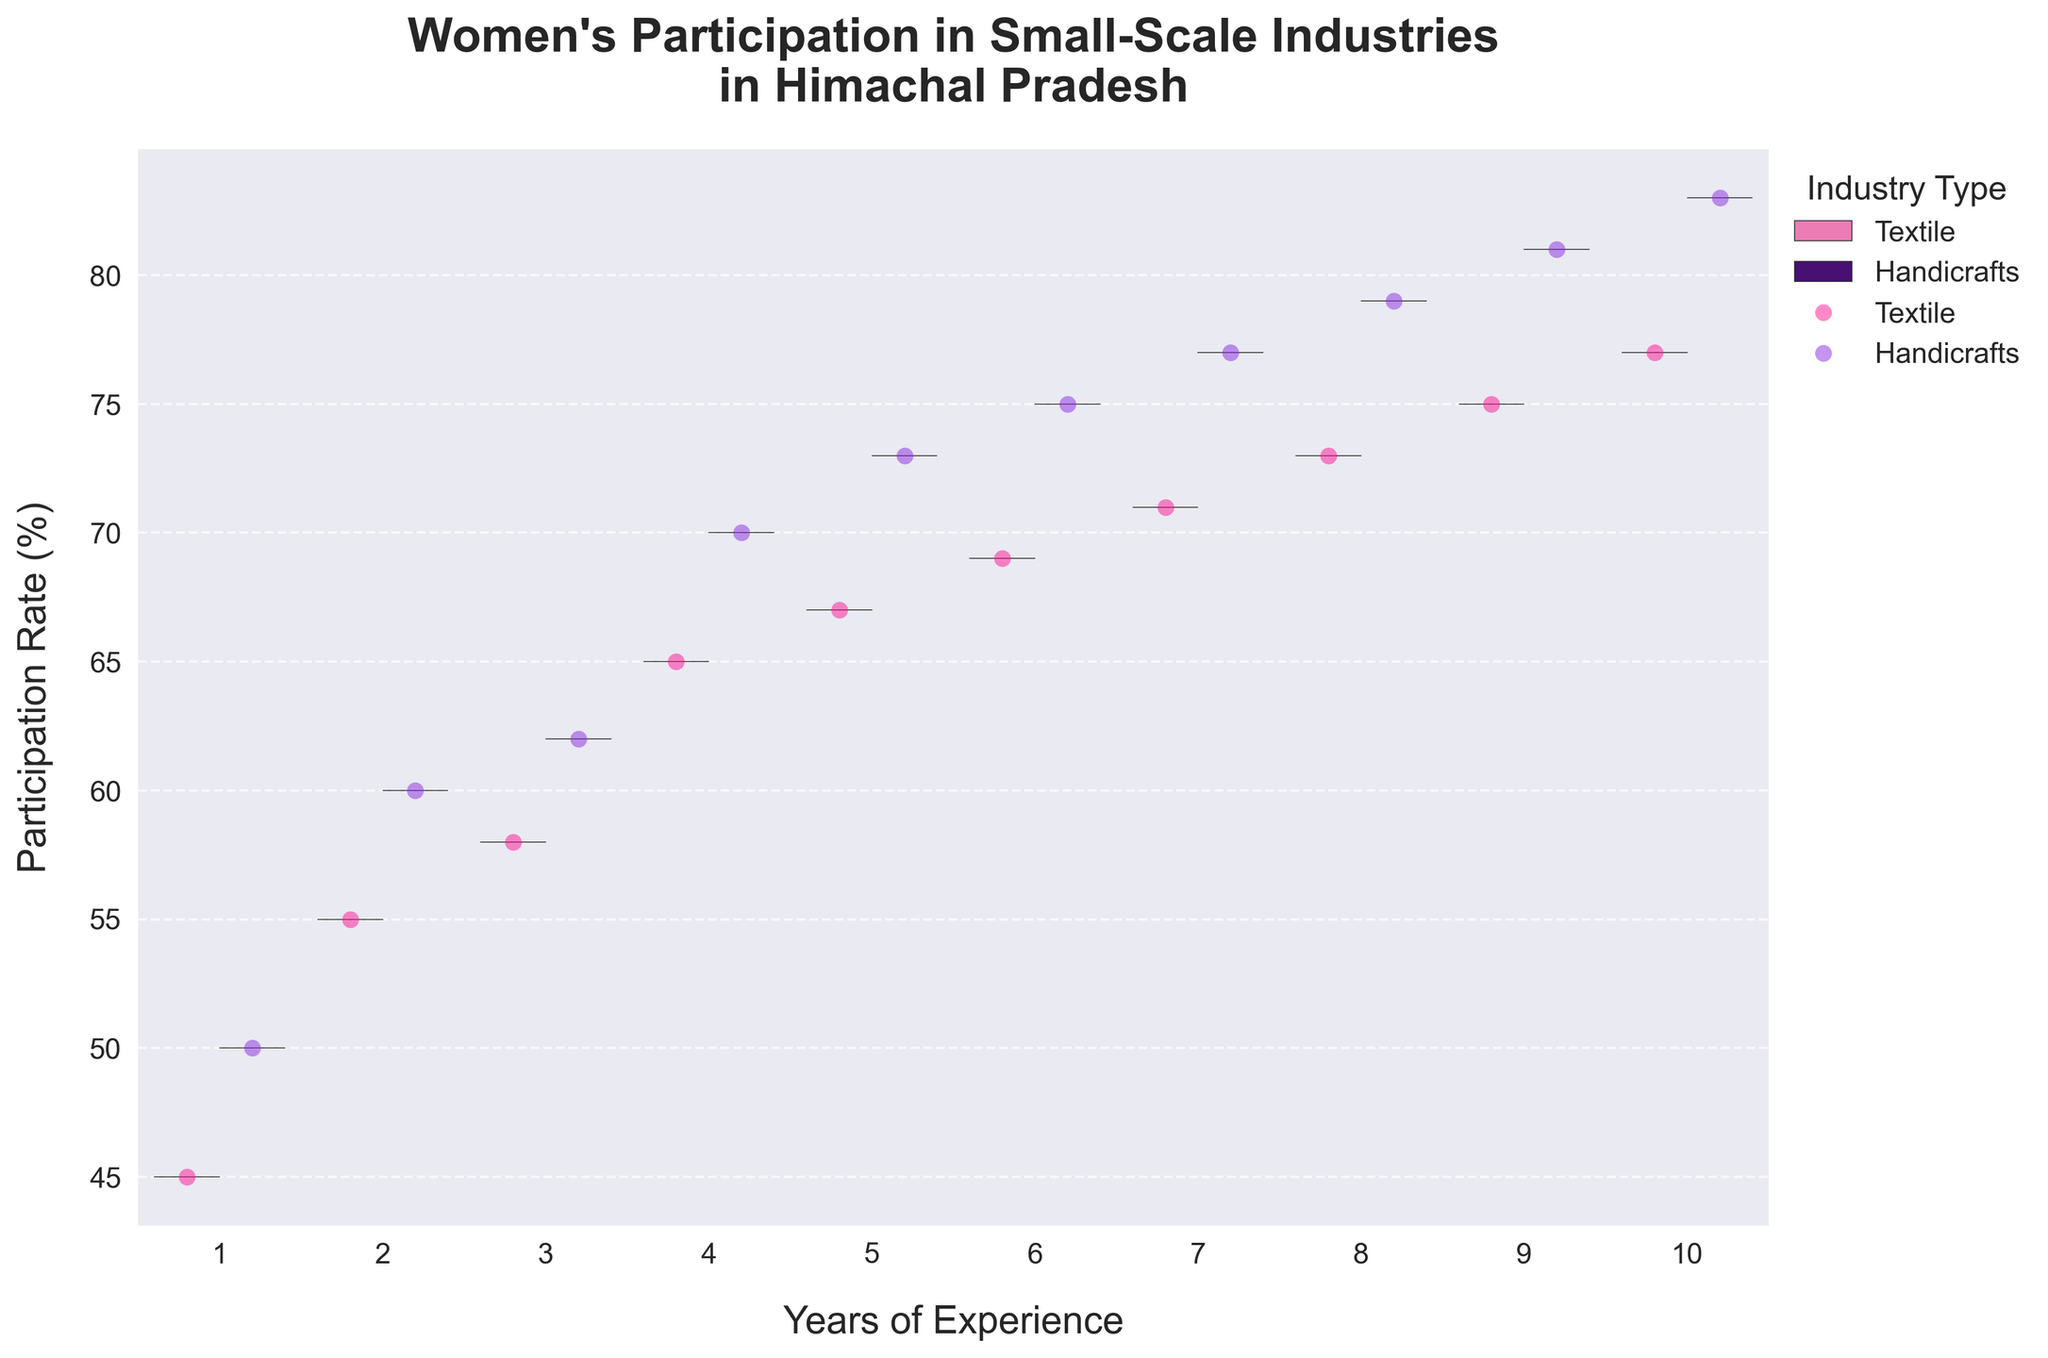How many years of experience are shown on the x-axis? The x-axis represents the years of experience. By counting the unique x-axis tick marks, we can determine the range of years shown.
Answer: 10 Which industry type shows higher participation rates across all years of experience? The violin plots and points indicate participation rates for Textile and Handicrafts. By comparing the positions of the median lines and the spread of each industry, Handicrafts consistently show higher participation rates across the years.
Answer: Handicrafts For women with 5 years of experience, what is the participation rate percentage for the Textile industry? On the violin chart, locate the data points for 5 years of experience and check the corresponding y-axis value for the Textile industry which is colored distinctively.
Answer: 67% What is the range of participation rates for women with 2 years of experience in the Handicrafts industry? Identify the violin plot and jittered points for 2 years under Handicrafts. The range will be the span between the lowest and highest points in that specific section.
Answer: 60% to 62% Between years 7 and 8, which year has a higher median participation rate for the Handicrafts industry? Analyze the inner quartile lines of the violin plots for both years for Handicrafts. The median is represented by the central line of the interquartile range.
Answer: 8 years What is the average participation rate for the Textile industry for the first 3 years? Sum the participation rates for Textile for years 1, 2, and 3. Divide the total by 3 to get the average. Calculation: (45% + 55% + 58%) / 3
Answer: 52.67% What is the difference in participation rates between Textile and Handicrafts for women with 10 years of experience? Find the data points for 10 years of experience. Calculate the difference by subtracting the participation rate of Textile from Handicrafts. Calculation: 83% - 77%
Answer: 6% Which year of experience shows the most spread in participation rates for both industries combined? Compare the width of the violin plots for each year. The year with the widest spread from top to bottom of the combined violin plot will indicate the most spread.
Answer: 10 years Can you observe any trend in the participation rates for both industries as the years of experience increase? Examine the violin plots and jittered points across the x-axis for both industries. There appears to be an increasing trend in participation rates for both industries as the years of experience increase.
Answer: Increasing trend What is the highest observed participation rate for women in the Handicrafts industry? Look for the highest jittered point on the y-axis corresponding to the Handicrafts industry segments in the plots.
Answer: 83% 